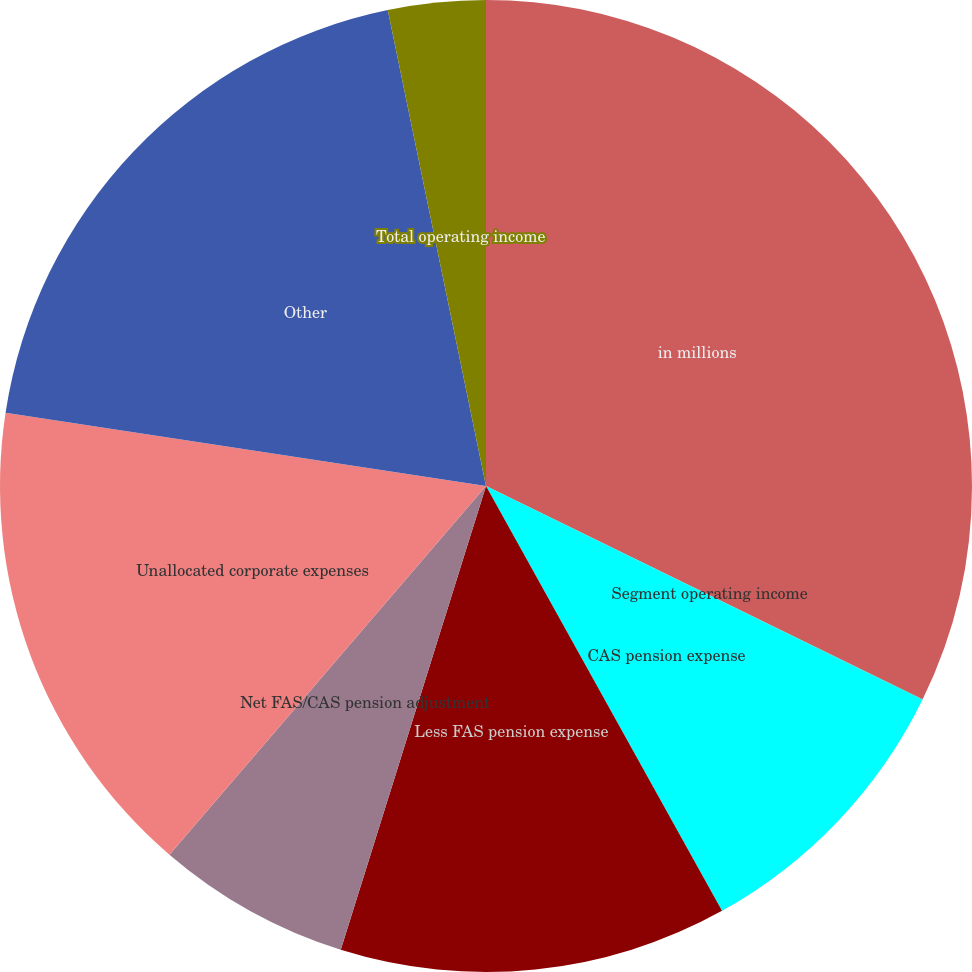Convert chart. <chart><loc_0><loc_0><loc_500><loc_500><pie_chart><fcel>in millions<fcel>Segment operating income<fcel>CAS pension expense<fcel>Less FAS pension expense<fcel>Net FAS/CAS pension adjustment<fcel>Unallocated corporate expenses<fcel>Other<fcel>Total operating income<nl><fcel>32.23%<fcel>0.02%<fcel>9.68%<fcel>12.9%<fcel>6.46%<fcel>16.12%<fcel>19.35%<fcel>3.24%<nl></chart> 